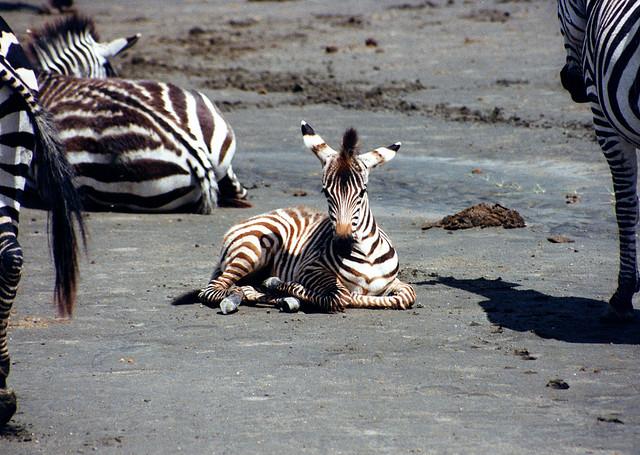What are the two colors on the zebra?
Short answer required. Black and white. How many tails are there?
Give a very brief answer. 3. Is this a baby zebra?
Short answer required. Yes. 